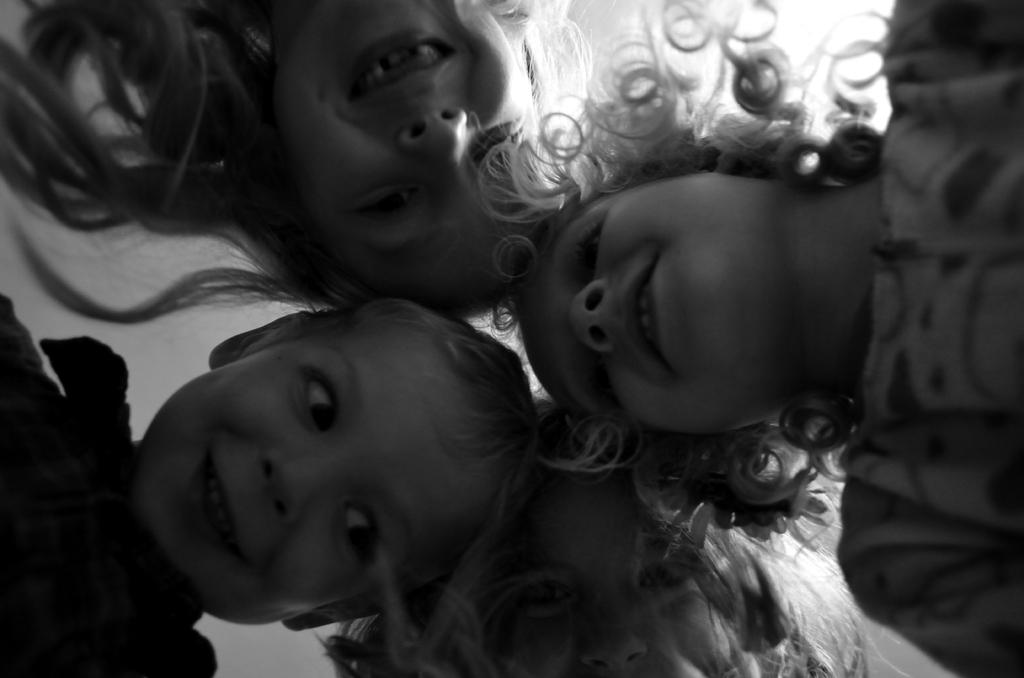What is the color scheme of the image? The image is black and white. What subjects are present in the image? There are kids in the image. How many jellyfish can be seen swimming in the image? There are no jellyfish present in the image; it features kids. What type of laughter can be heard coming from the kids in the image? The image is a still photograph, so there is no sound or laughter present. 